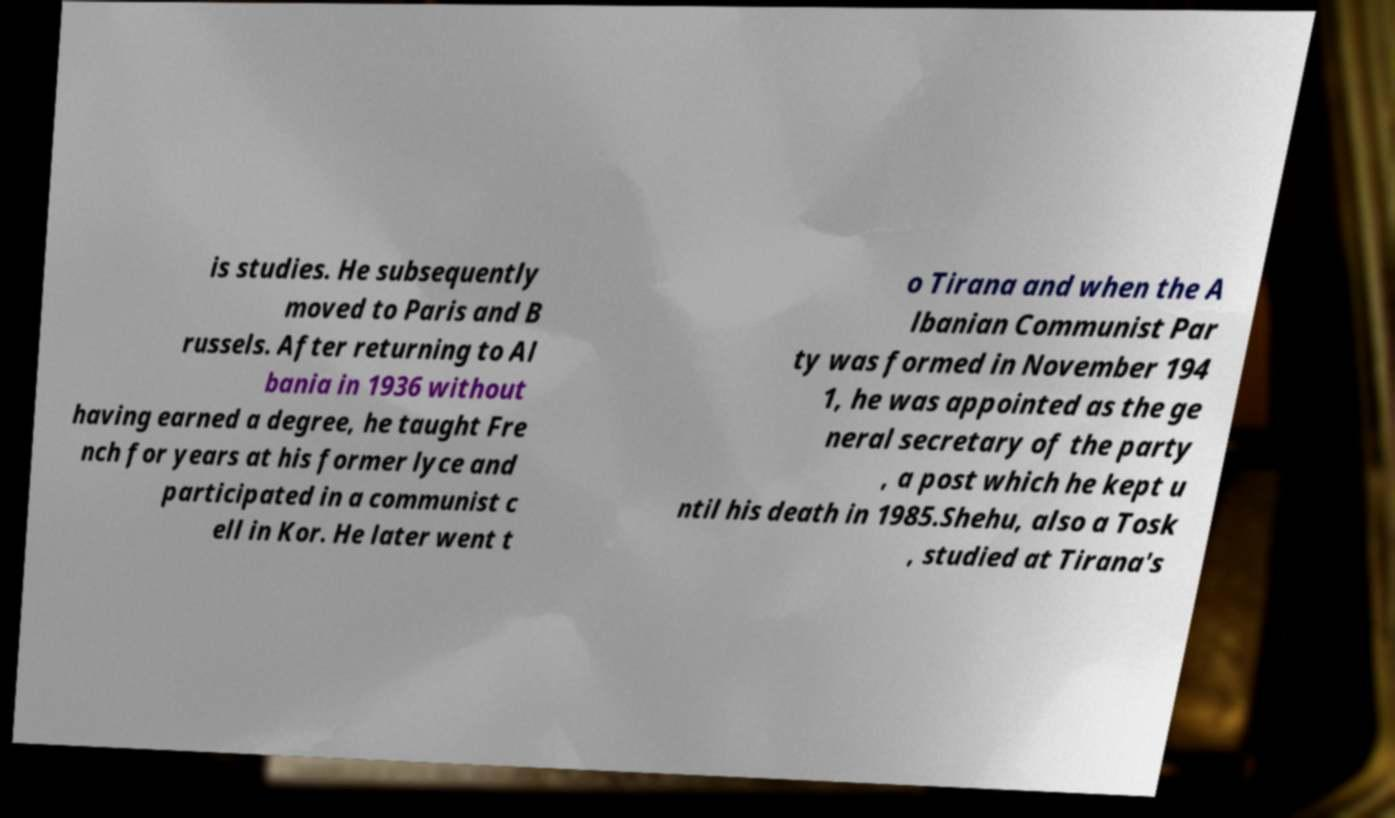Please identify and transcribe the text found in this image. is studies. He subsequently moved to Paris and B russels. After returning to Al bania in 1936 without having earned a degree, he taught Fre nch for years at his former lyce and participated in a communist c ell in Kor. He later went t o Tirana and when the A lbanian Communist Par ty was formed in November 194 1, he was appointed as the ge neral secretary of the party , a post which he kept u ntil his death in 1985.Shehu, also a Tosk , studied at Tirana's 